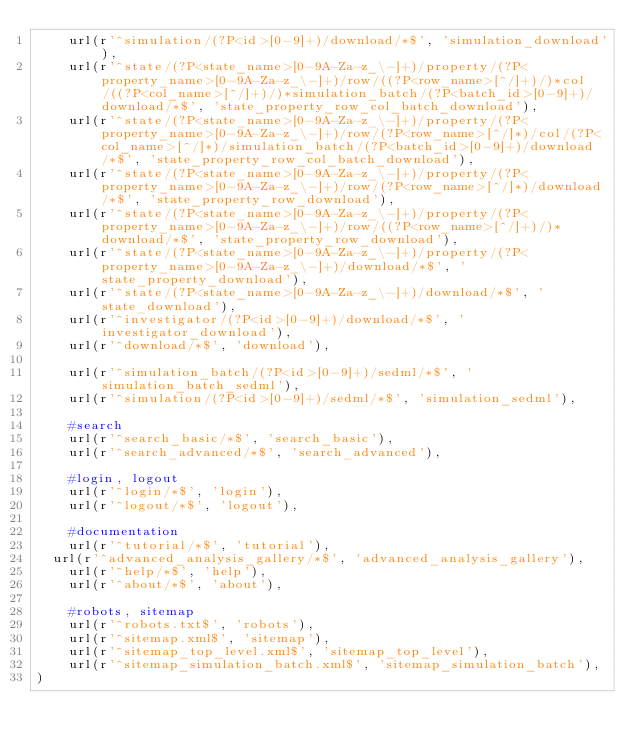Convert code to text. <code><loc_0><loc_0><loc_500><loc_500><_Python_>    url(r'^simulation/(?P<id>[0-9]+)/download/*$', 'simulation_download'),    
    url(r'^state/(?P<state_name>[0-9A-Za-z_\-]+)/property/(?P<property_name>[0-9A-Za-z_\-]+)/row/((?P<row_name>[^/]+)/)*col/((?P<col_name>[^/]+)/)*simulation_batch/(?P<batch_id>[0-9]+)/download/*$', 'state_property_row_col_batch_download'),
    url(r'^state/(?P<state_name>[0-9A-Za-z_\-]+)/property/(?P<property_name>[0-9A-Za-z_\-]+)/row/(?P<row_name>[^/]*)/col/(?P<col_name>[^/]*)/simulation_batch/(?P<batch_id>[0-9]+)/download/*$', 'state_property_row_col_batch_download'),
    url(r'^state/(?P<state_name>[0-9A-Za-z_\-]+)/property/(?P<property_name>[0-9A-Za-z_\-]+)/row/(?P<row_name>[^/]*)/download/*$', 'state_property_row_download'),
    url(r'^state/(?P<state_name>[0-9A-Za-z_\-]+)/property/(?P<property_name>[0-9A-Za-z_\-]+)/row/((?P<row_name>[^/]+)/)*download/*$', 'state_property_row_download'),
    url(r'^state/(?P<state_name>[0-9A-Za-z_\-]+)/property/(?P<property_name>[0-9A-Za-z_\-]+)/download/*$', 'state_property_download'),
    url(r'^state/(?P<state_name>[0-9A-Za-z_\-]+)/download/*$', 'state_download'),
    url(r'^investigator/(?P<id>[0-9]+)/download/*$', 'investigator_download'),
    url(r'^download/*$', 'download'),
    
    url(r'^simulation_batch/(?P<id>[0-9]+)/sedml/*$', 'simulation_batch_sedml'),
    url(r'^simulation/(?P<id>[0-9]+)/sedml/*$', 'simulation_sedml'),
    
    #search
    url(r'^search_basic/*$', 'search_basic'),
    url(r'^search_advanced/*$', 'search_advanced'),
    
    #login, logout
    url(r'^login/*$', 'login'),
    url(r'^logout/*$', 'logout'),
    
    #documentation
    url(r'^tutorial/*$', 'tutorial'),
	url(r'^advanced_analysis_gallery/*$', 'advanced_analysis_gallery'),
    url(r'^help/*$', 'help'),
    url(r'^about/*$', 'about'),
    
    #robots, sitemap
    url(r'^robots.txt$', 'robots'),
    url(r'^sitemap.xml$', 'sitemap'),
    url(r'^sitemap_top_level.xml$', 'sitemap_top_level'),
    url(r'^sitemap_simulation_batch.xml$', 'sitemap_simulation_batch'),
)
</code> 